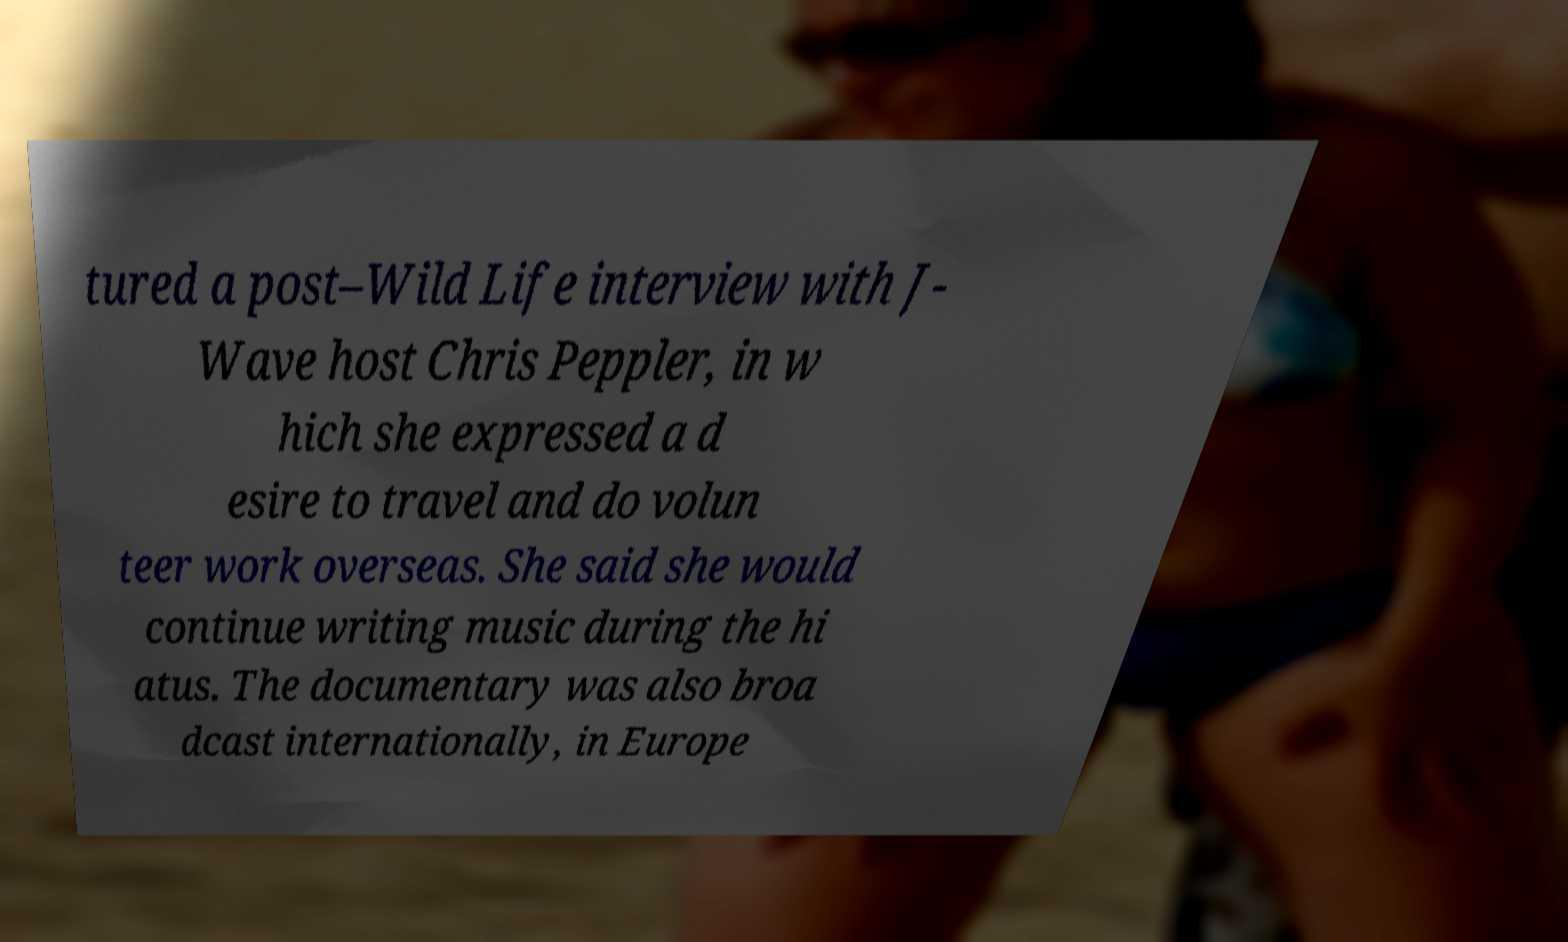Please identify and transcribe the text found in this image. tured a post–Wild Life interview with J- Wave host Chris Peppler, in w hich she expressed a d esire to travel and do volun teer work overseas. She said she would continue writing music during the hi atus. The documentary was also broa dcast internationally, in Europe 